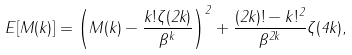Convert formula to latex. <formula><loc_0><loc_0><loc_500><loc_500>E [ M ( k ) ] = \left ( M ( k ) - \frac { k ! \zeta ( 2 k ) } { \beta ^ { k } } \right ) ^ { 2 } + \frac { ( 2 k ) ! - k ! ^ { 2 } } { \beta ^ { 2 k } } \zeta ( 4 k ) ,</formula> 